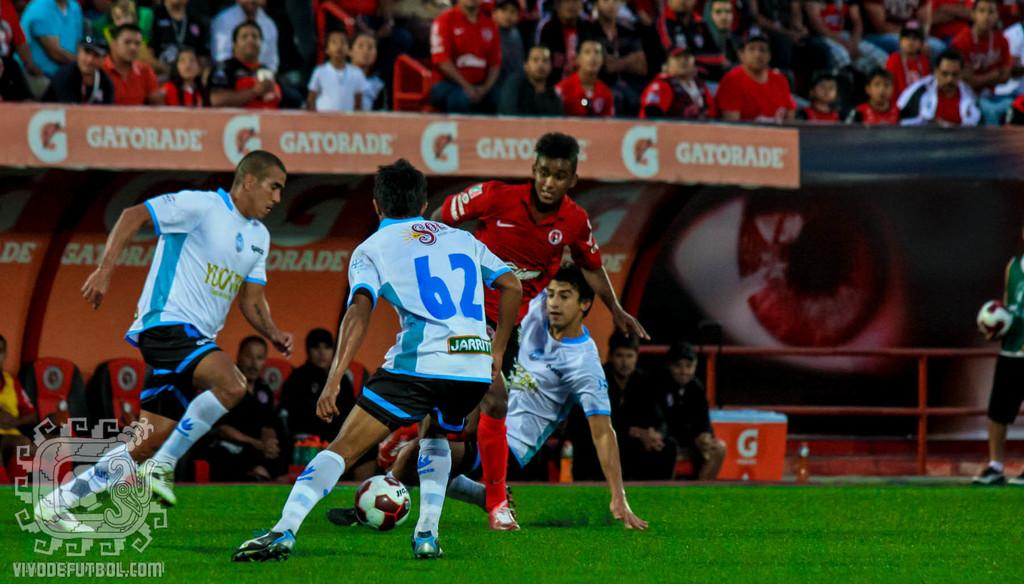<image>
Create a compact narrative representing the image presented. Player 62 is in a clump of other players going for the soccer ball. 